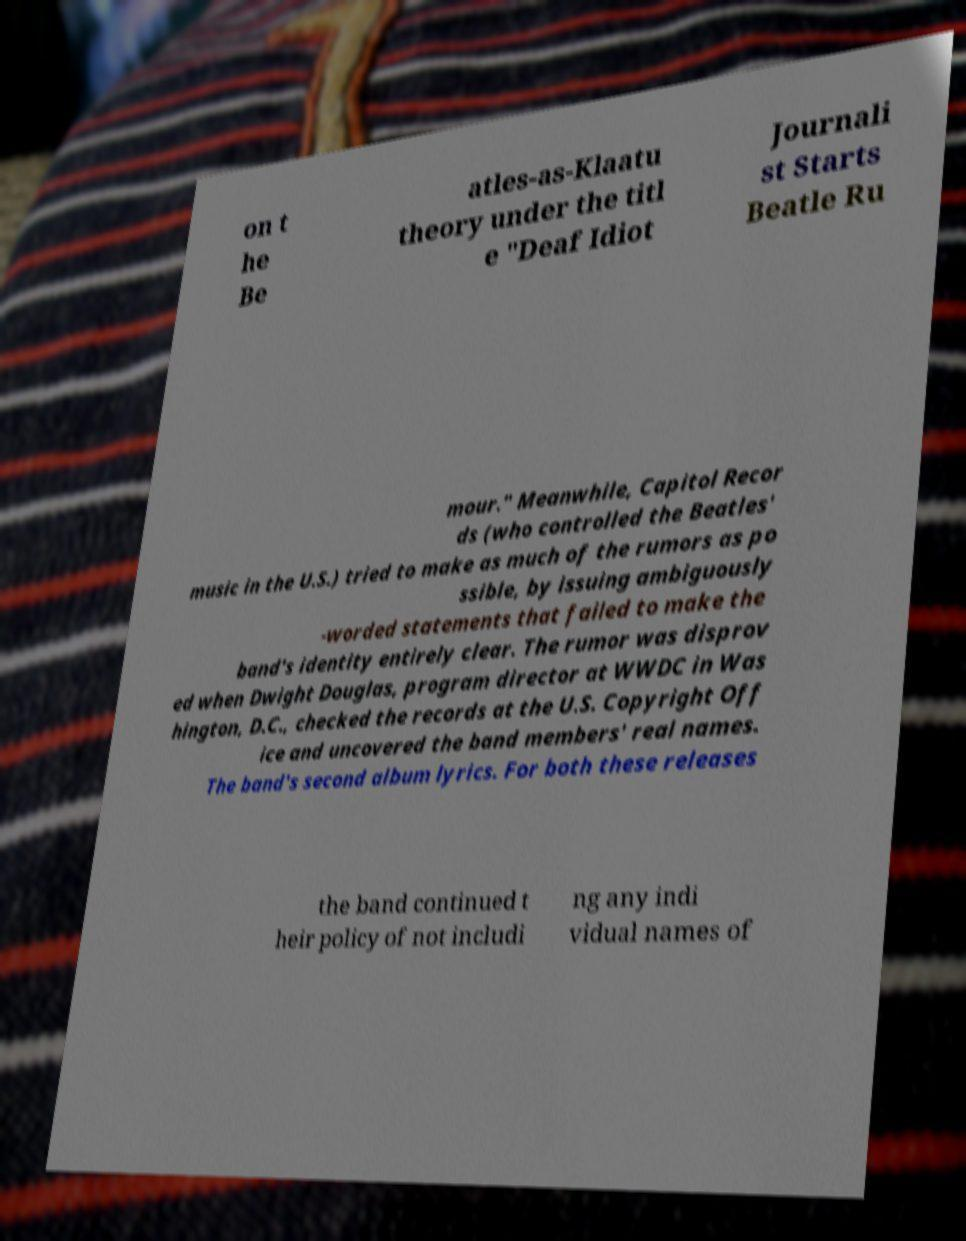Please read and relay the text visible in this image. What does it say? on t he Be atles-as-Klaatu theory under the titl e "Deaf Idiot Journali st Starts Beatle Ru mour." Meanwhile, Capitol Recor ds (who controlled the Beatles' music in the U.S.) tried to make as much of the rumors as po ssible, by issuing ambiguously -worded statements that failed to make the band's identity entirely clear. The rumor was disprov ed when Dwight Douglas, program director at WWDC in Was hington, D.C., checked the records at the U.S. Copyright Off ice and uncovered the band members' real names. The band's second album lyrics. For both these releases the band continued t heir policy of not includi ng any indi vidual names of 